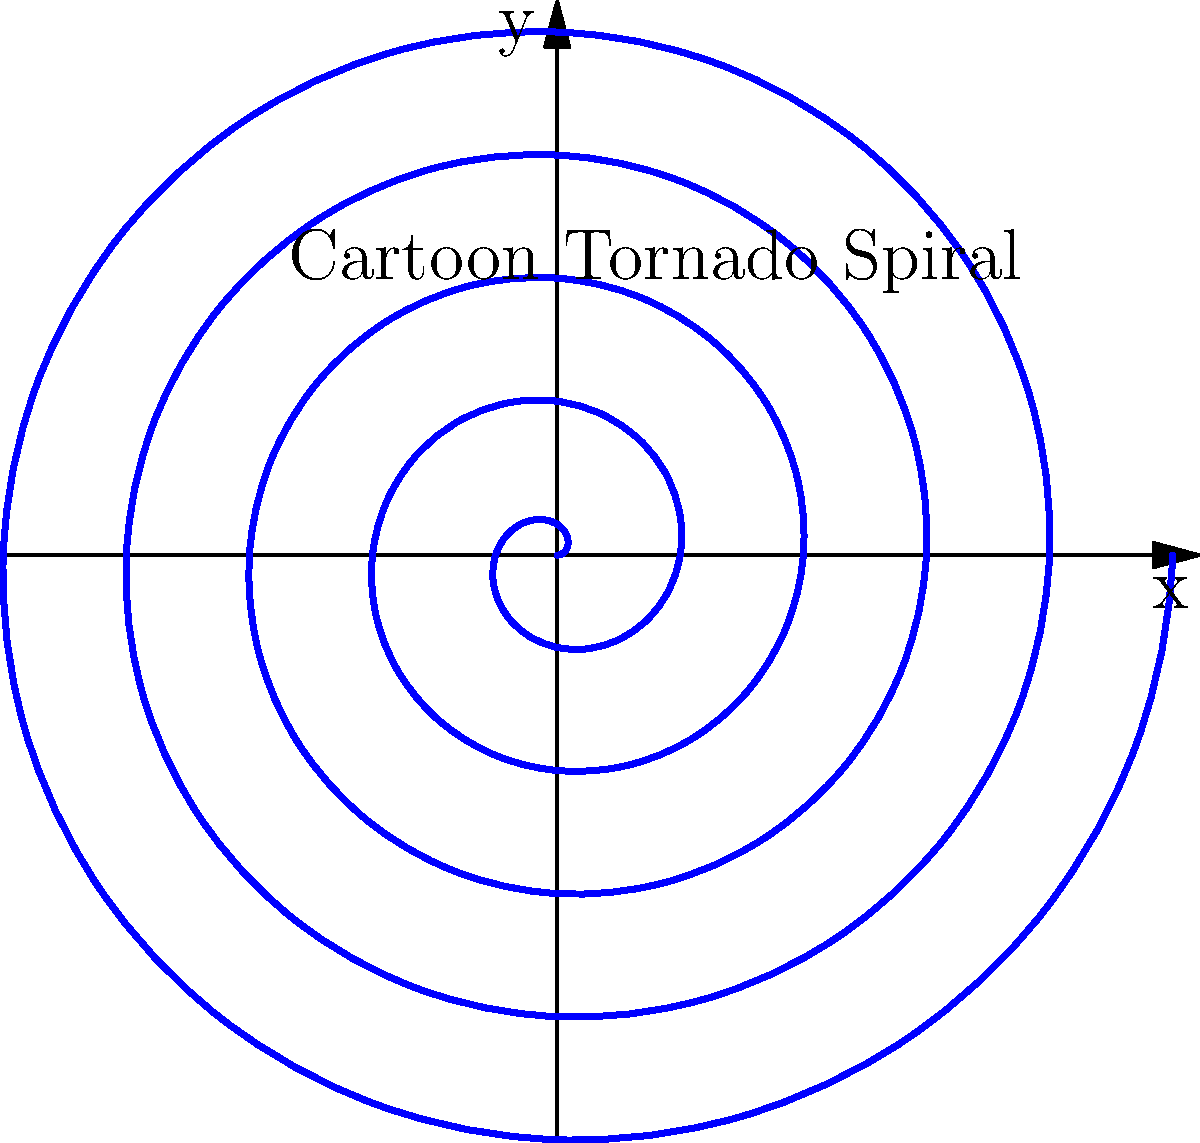In a classic cartoon, a mischievous tornado is depicted as a swirling spiral. The motion of this tornado can be represented by the parametric equations $x = at\cos(t)$ and $y = at\sin(t)$, where $a$ is a constant and $t$ is the parameter. If the tornado makes one complete revolution when $t = 2\pi$, what is the polar equation of this spiral? Let's approach this step-by-step:

1) The parametric equations given are:
   $x = at\cos(t)$
   $y = at\sin(t)$

2) To convert from parametric to polar form, we need to express $r$ in terms of $\theta$.

3) In polar coordinates:
   $x = r\cos(\theta)$
   $y = r\sin(\theta)$

4) Comparing these with our parametric equations, we can see that:
   $r\cos(\theta) = at\cos(t)$
   $r\sin(\theta) = at\sin(t)$

5) This implies that $\theta = t$ and $r = at$

6) Therefore, the polar equation is:
   $r = a\theta$

7) However, we need to consider the condition that one complete revolution occurs when $t = 2\pi$. In polar form, this means the spiral should return to its starting point after an angle of $2\pi$.

8) To achieve this, we need to modify our equation:
   $r = \frac{a}{2\pi}\theta$

9) This ensures that when $\theta = 2\pi$, $r$ has increased by exactly $a$, completing one revolution of the spiral.
Answer: $r = \frac{a}{2\pi}\theta$ 